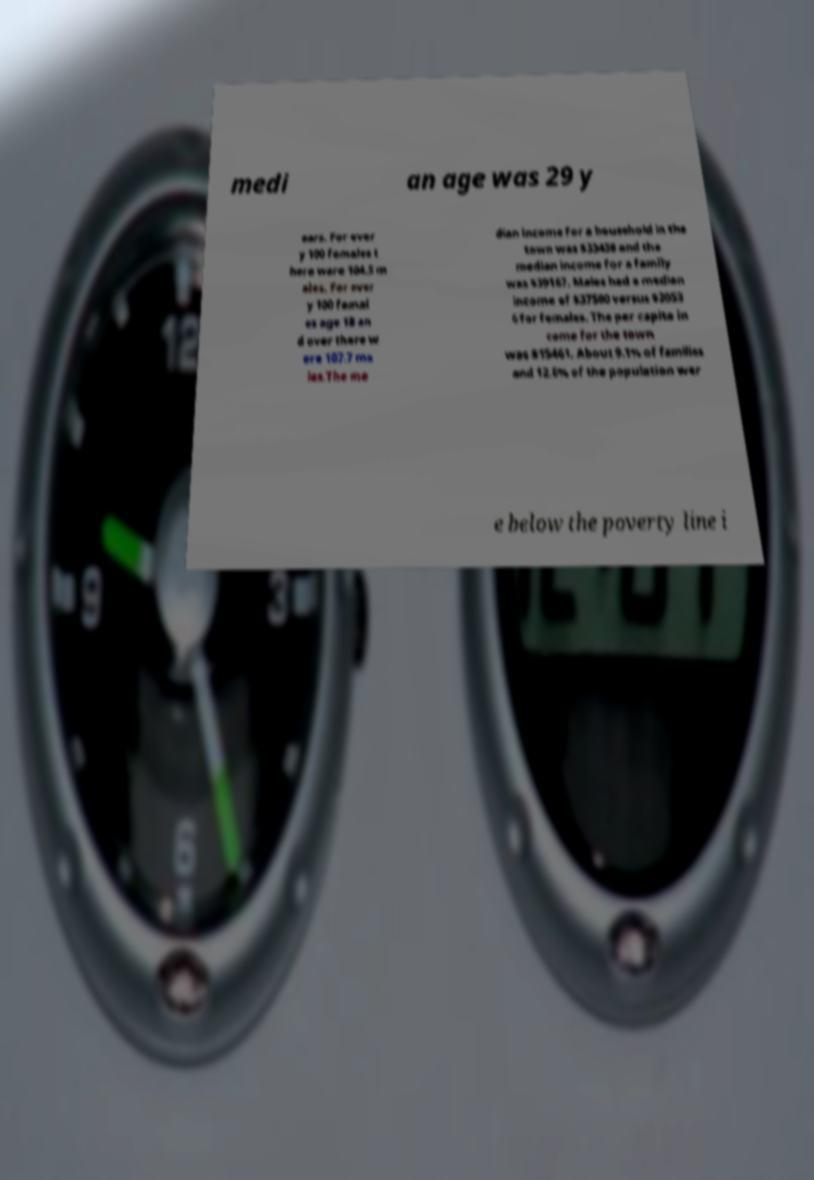Could you extract and type out the text from this image? medi an age was 29 y ears. For ever y 100 females t here were 104.5 m ales. For ever y 100 femal es age 18 an d over there w ere 107.7 ma les.The me dian income for a household in the town was $33438 and the median income for a family was $39167. Males had a median income of $37500 versus $2053 6 for females. The per capita in come for the town was $15461. About 9.1% of families and 12.6% of the population wer e below the poverty line i 